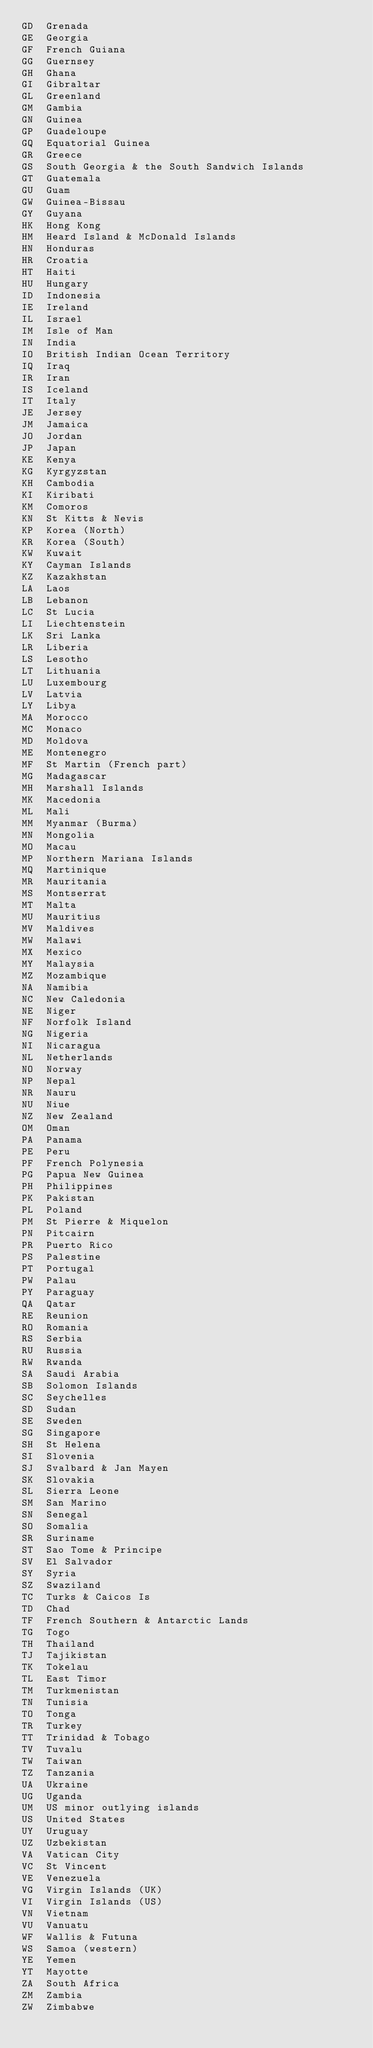Convert code to text. <code><loc_0><loc_0><loc_500><loc_500><_SQL_>GD	Grenada
GE	Georgia
GF	French Guiana
GG	Guernsey
GH	Ghana
GI	Gibraltar
GL	Greenland
GM	Gambia
GN	Guinea
GP	Guadeloupe
GQ	Equatorial Guinea
GR	Greece
GS	South Georgia & the South Sandwich Islands
GT	Guatemala
GU	Guam
GW	Guinea-Bissau
GY	Guyana
HK	Hong Kong
HM	Heard Island & McDonald Islands
HN	Honduras
HR	Croatia
HT	Haiti
HU	Hungary
ID	Indonesia
IE	Ireland
IL	Israel
IM	Isle of Man
IN	India
IO	British Indian Ocean Territory
IQ	Iraq
IR	Iran
IS	Iceland
IT	Italy
JE	Jersey
JM	Jamaica
JO	Jordan
JP	Japan
KE	Kenya
KG	Kyrgyzstan
KH	Cambodia
KI	Kiribati
KM	Comoros
KN	St Kitts & Nevis
KP	Korea (North)
KR	Korea (South)
KW	Kuwait
KY	Cayman Islands
KZ	Kazakhstan
LA	Laos
LB	Lebanon
LC	St Lucia
LI	Liechtenstein
LK	Sri Lanka
LR	Liberia
LS	Lesotho
LT	Lithuania
LU	Luxembourg
LV	Latvia
LY	Libya
MA	Morocco
MC	Monaco
MD	Moldova
ME	Montenegro
MF	St Martin (French part)
MG	Madagascar
MH	Marshall Islands
MK	Macedonia
ML	Mali
MM	Myanmar (Burma)
MN	Mongolia
MO	Macau
MP	Northern Mariana Islands
MQ	Martinique
MR	Mauritania
MS	Montserrat
MT	Malta
MU	Mauritius
MV	Maldives
MW	Malawi
MX	Mexico
MY	Malaysia
MZ	Mozambique
NA	Namibia
NC	New Caledonia
NE	Niger
NF	Norfolk Island
NG	Nigeria
NI	Nicaragua
NL	Netherlands
NO	Norway
NP	Nepal
NR	Nauru
NU	Niue
NZ	New Zealand
OM	Oman
PA	Panama
PE	Peru
PF	French Polynesia
PG	Papua New Guinea
PH	Philippines
PK	Pakistan
PL	Poland
PM	St Pierre & Miquelon
PN	Pitcairn
PR	Puerto Rico
PS	Palestine
PT	Portugal
PW	Palau
PY	Paraguay
QA	Qatar
RE	Reunion
RO	Romania
RS	Serbia
RU	Russia
RW	Rwanda
SA	Saudi Arabia
SB	Solomon Islands
SC	Seychelles
SD	Sudan
SE	Sweden
SG	Singapore
SH	St Helena
SI	Slovenia
SJ	Svalbard & Jan Mayen
SK	Slovakia
SL	Sierra Leone
SM	San Marino
SN	Senegal
SO	Somalia
SR	Suriname
ST	Sao Tome & Principe
SV	El Salvador
SY	Syria
SZ	Swaziland
TC	Turks & Caicos Is
TD	Chad
TF	French Southern & Antarctic Lands
TG	Togo
TH	Thailand
TJ	Tajikistan
TK	Tokelau
TL	East Timor
TM	Turkmenistan
TN	Tunisia
TO	Tonga
TR	Turkey
TT	Trinidad & Tobago
TV	Tuvalu
TW	Taiwan
TZ	Tanzania
UA	Ukraine
UG	Uganda
UM	US minor outlying islands
US	United States
UY	Uruguay
UZ	Uzbekistan
VA	Vatican City
VC	St Vincent
VE	Venezuela
VG	Virgin Islands (UK)
VI	Virgin Islands (US)
VN	Vietnam
VU	Vanuatu
WF	Wallis & Futuna
WS	Samoa (western)
YE	Yemen
YT	Mayotte
ZA	South Africa
ZM	Zambia
ZW	Zimbabwe
</code> 